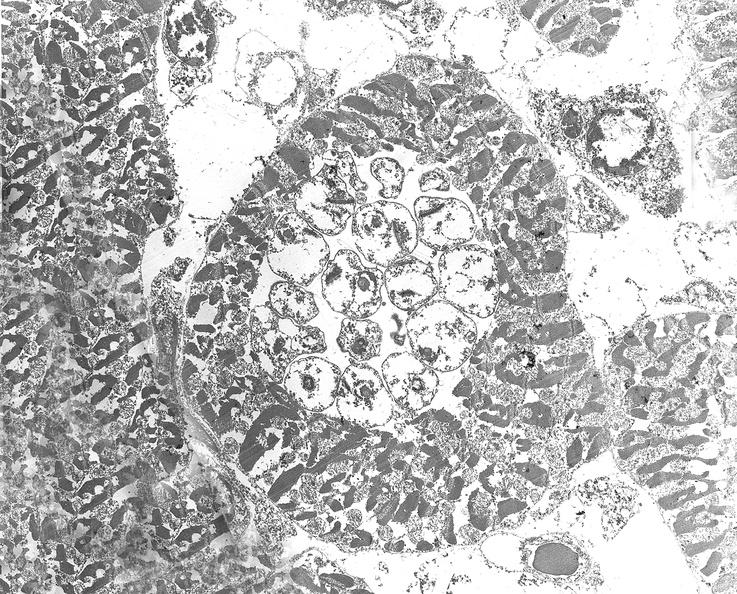what does this image show?
Answer the question using a single word or phrase. Chagas disease 